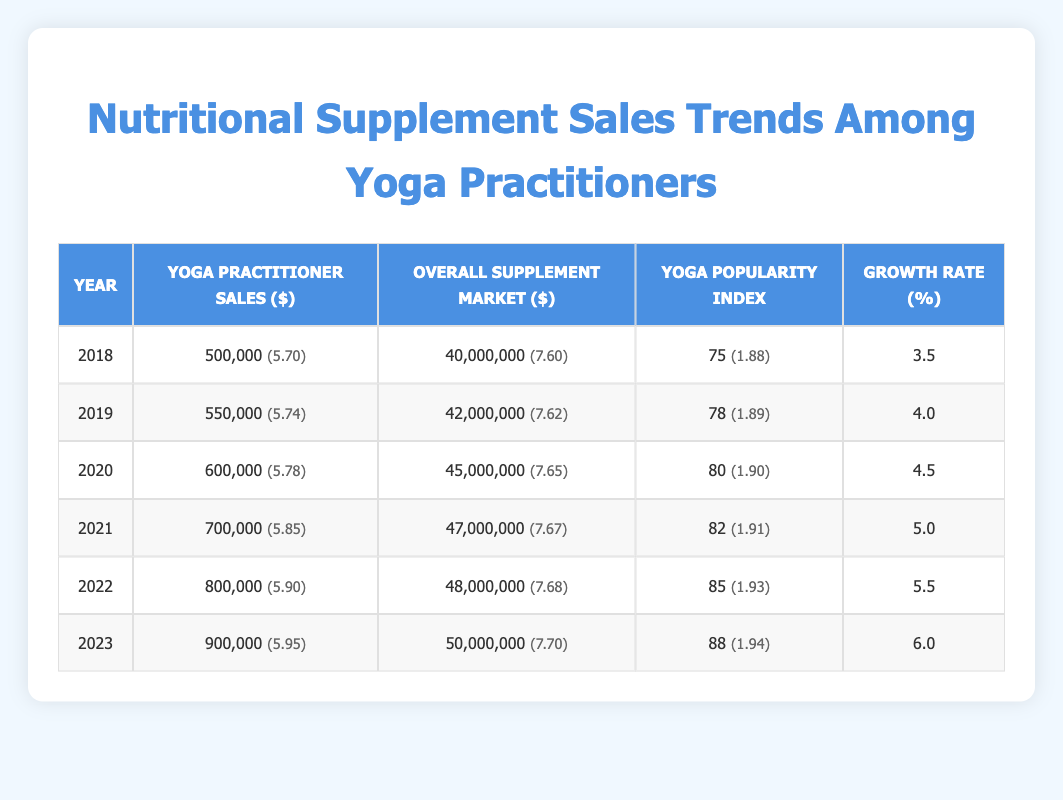What were the Yoga Practitioner Sales in 2020? The table shows that in the year 2020, the Yoga Practitioner Sales were 600,000.
Answer: 600,000 What is the Growth Rate for 2023? According to the table, the Growth Rate for the year 2023 is 6.0%.
Answer: 6.0% What was the overall supplement market size in 2021? The table indicates that the overall supplement market size in 2021 was 47,000,000.
Answer: 47,000,000 What is the average Yoga Practitioner Sales from 2018 to 2023? To find the average, sum the Yoga Practitioner Sales from 2018 to 2023, which is 500,000 + 550,000 + 600,000 + 700,000 + 800,000 + 900,000 = 4,100,000. There are 6 years, so the average is 4,100,000 / 6 = 683,333.33. Therefore, the average value is approximately 683,333.
Answer: 683,333 Was the Yoga Popularity Index in 2022 greater than 80? The table shows that the Yoga Popularity Index in 2022 was 85, which is indeed greater than 80.
Answer: Yes What was the percentage increase in Yoga Practitioner Sales from 2019 to 2021? The Yoga Practitioner Sales in 2019 was 550,000 and in 2021 it was 700,000. The increase is 700,000 - 550,000 = 150,000. To find the percentage increase, divide the increase by the original value (550,000) and multiply by 100: (150,000 / 550,000) * 100 = 27.27%. So, the percentage increase is approximately 27.27%.
Answer: 27.27% Is the Yoga Popularity Index steadily increasing each year from 2018 to 2023? By examining the table, we can see that the Yoga Popularity Index increased from 75 in 2018 to 88 in 2023, indicating a steady increase each year.
Answer: Yes What is the difference in overall supplement market size between 2022 and 2023? From the table, the overall supplement market size in 2022 is 48,000,000 and in 2023 is 50,000,000. The difference is 50,000,000 - 48,000,000 = 2,000,000.
Answer: 2,000,000 What was the Yoga Practitioner Sales growth from 2018 to 2022? Yoga Practitioner Sales increased from 500,000 in 2018 to 800,000 in 2022. The growth is 800,000 - 500,000 = 300,000. To find the percentage growth, divide the growth by the original value (500,000): (300,000 / 500,000) * 100 = 60%. Therefore, the sales growth from 2018 to 2022 is 60%.
Answer: 60% 